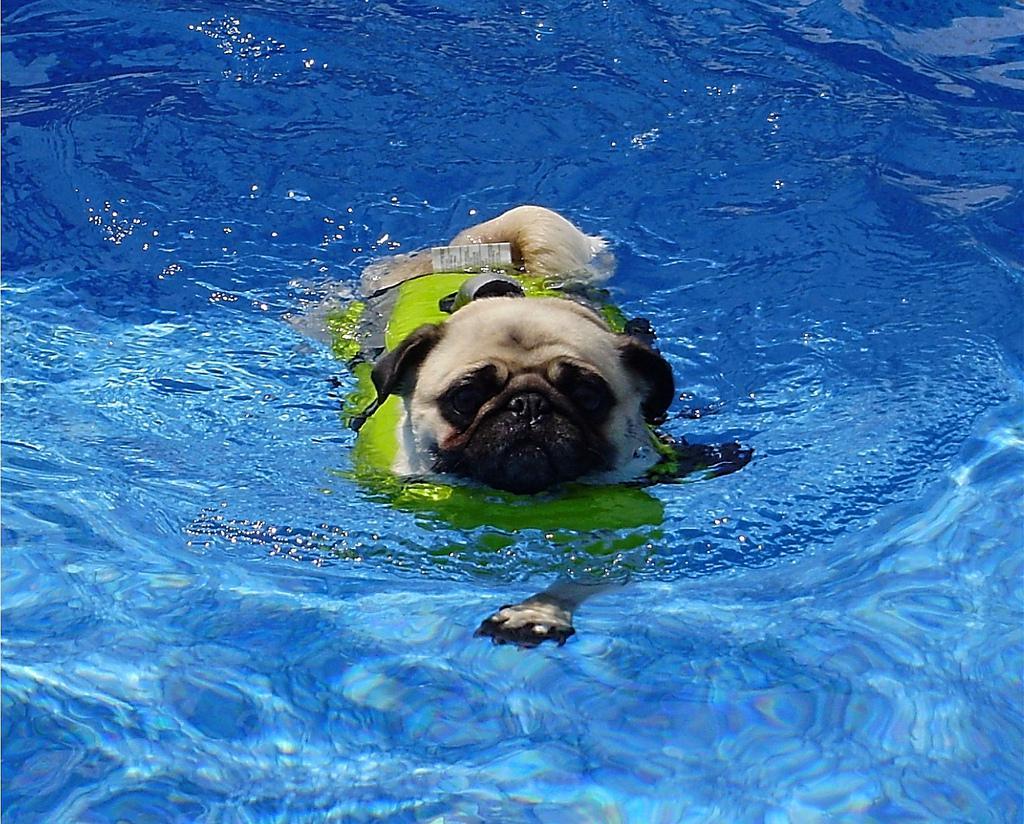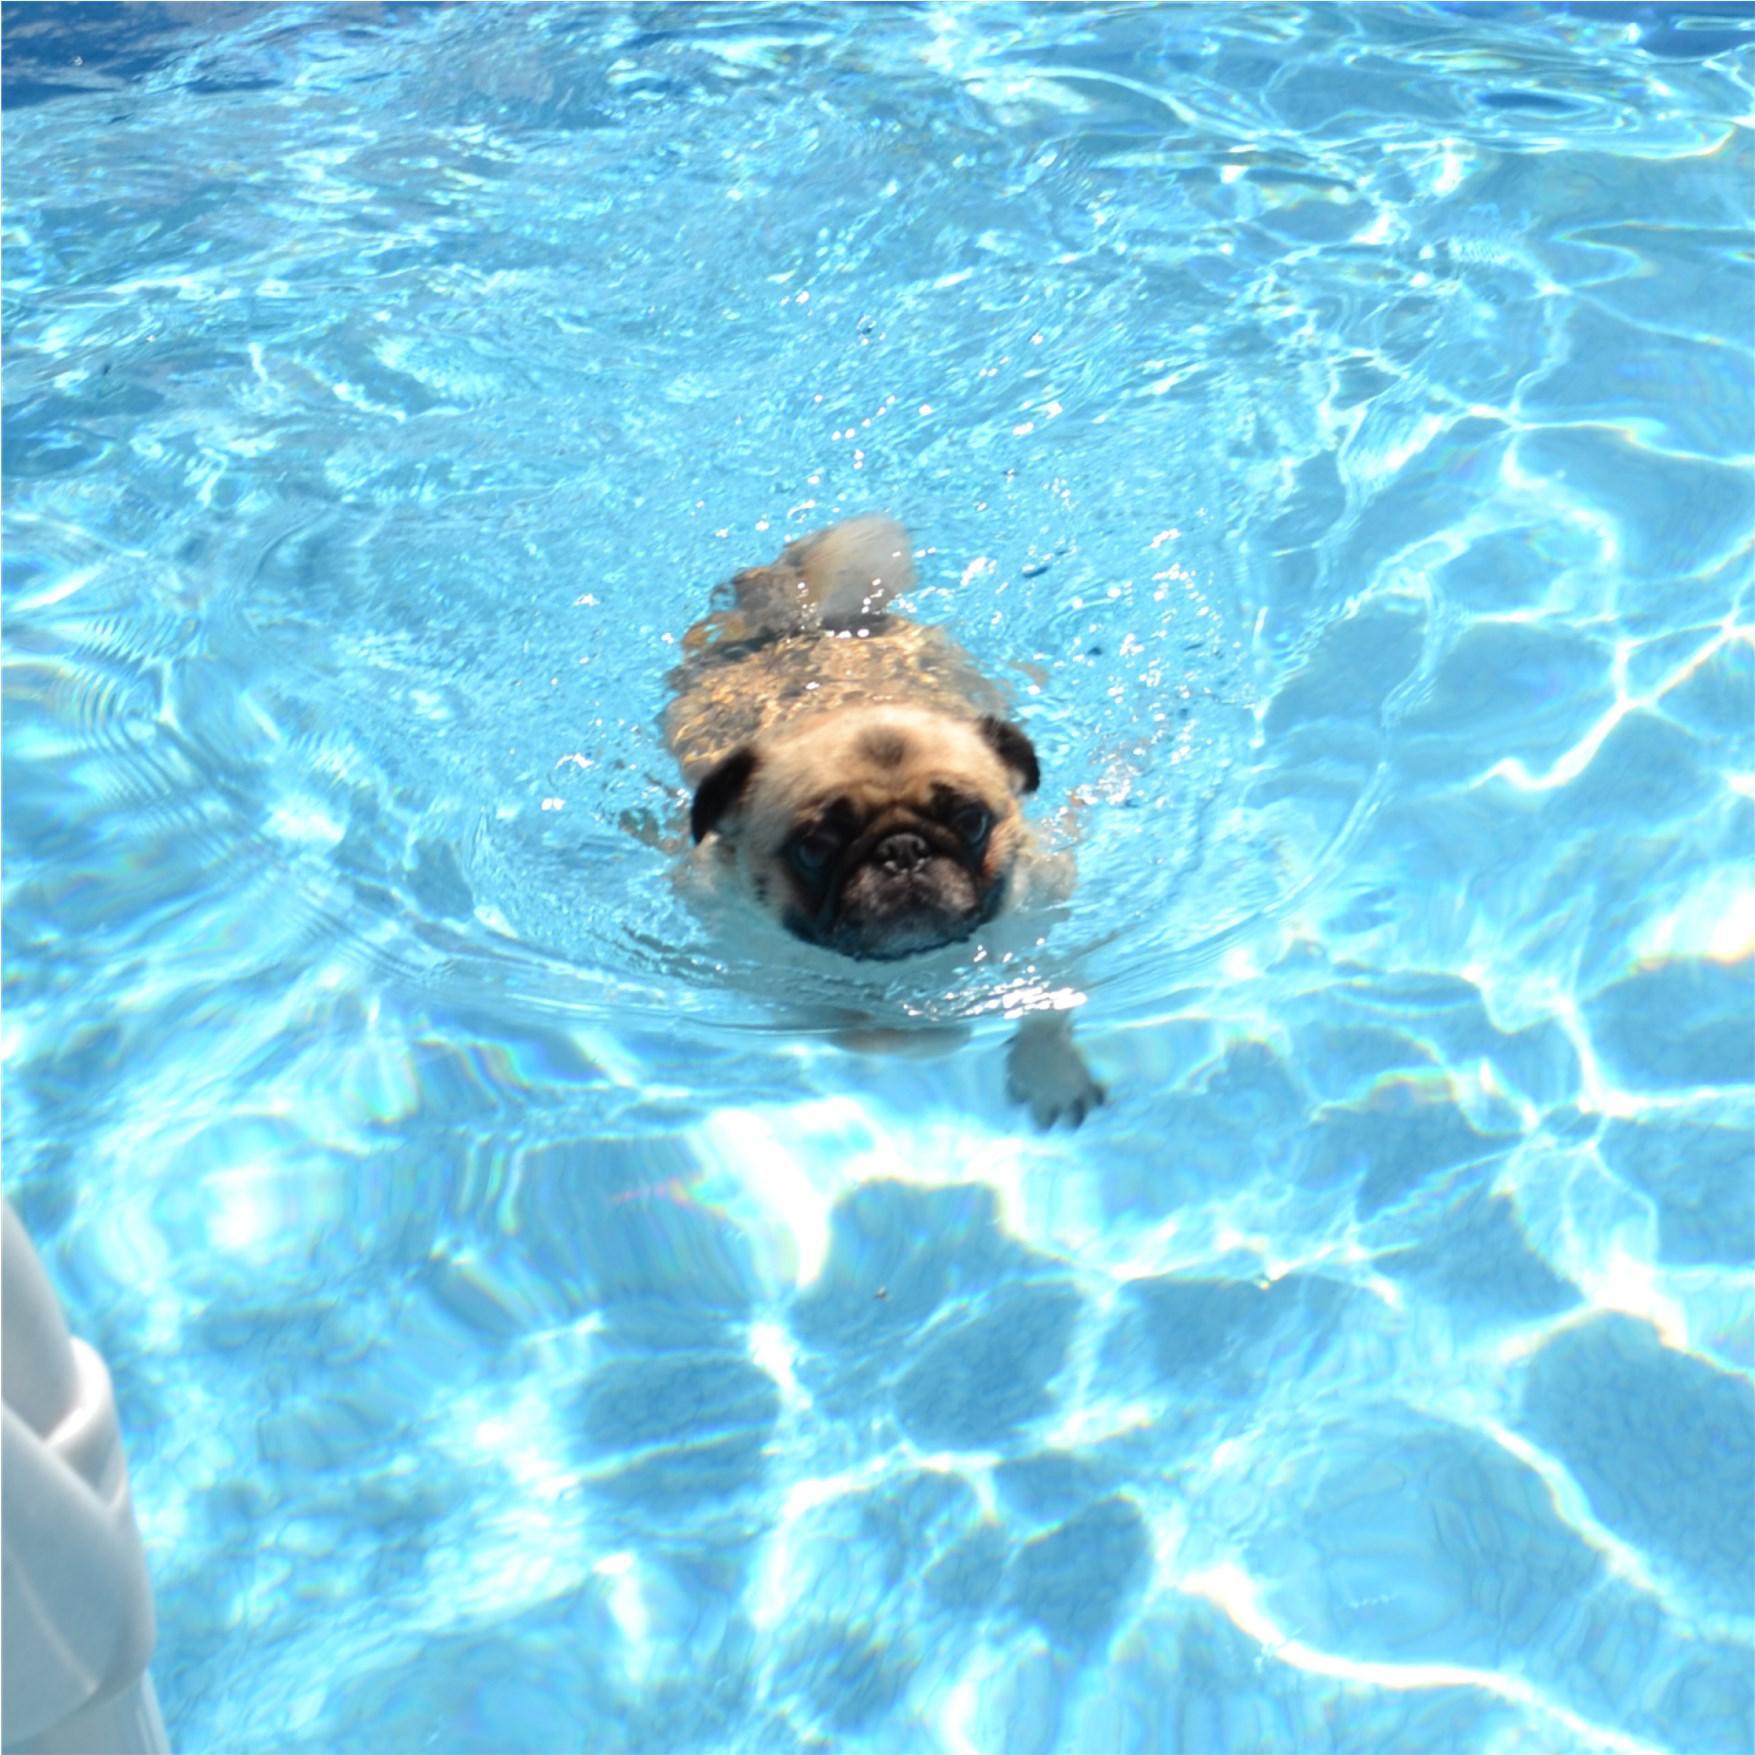The first image is the image on the left, the second image is the image on the right. Considering the images on both sides, is "there is a pug floating in a pool in an inter tube, the tube has a collage of images all over it" valid? Answer yes or no. No. The first image is the image on the left, the second image is the image on the right. For the images shown, is this caption "In at least one image there is a pug in an intertube with his legs hanging down." true? Answer yes or no. No. 